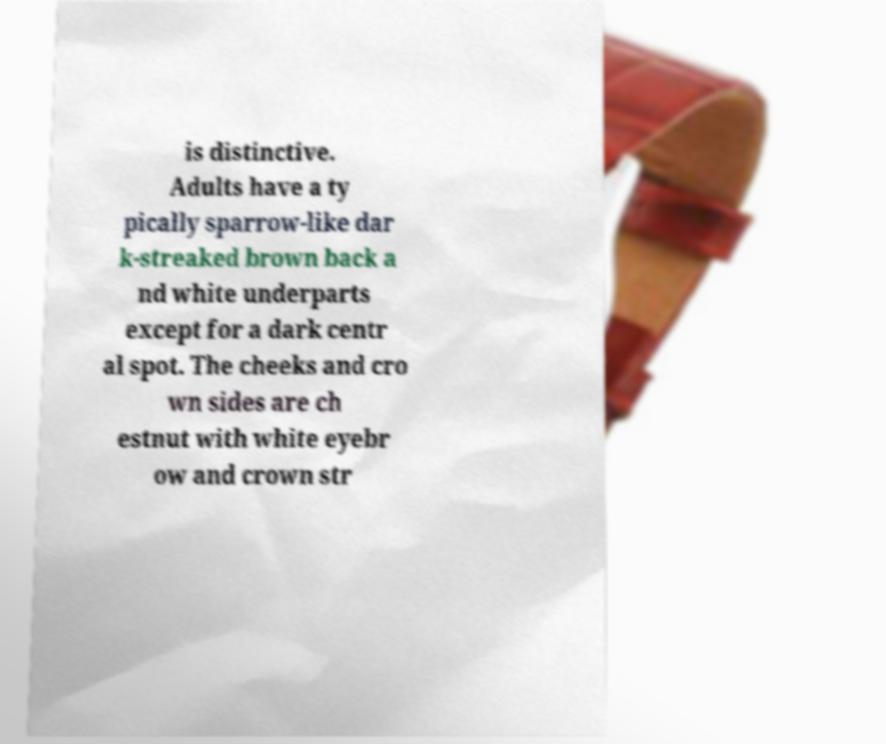What messages or text are displayed in this image? I need them in a readable, typed format. is distinctive. Adults have a ty pically sparrow-like dar k-streaked brown back a nd white underparts except for a dark centr al spot. The cheeks and cro wn sides are ch estnut with white eyebr ow and crown str 